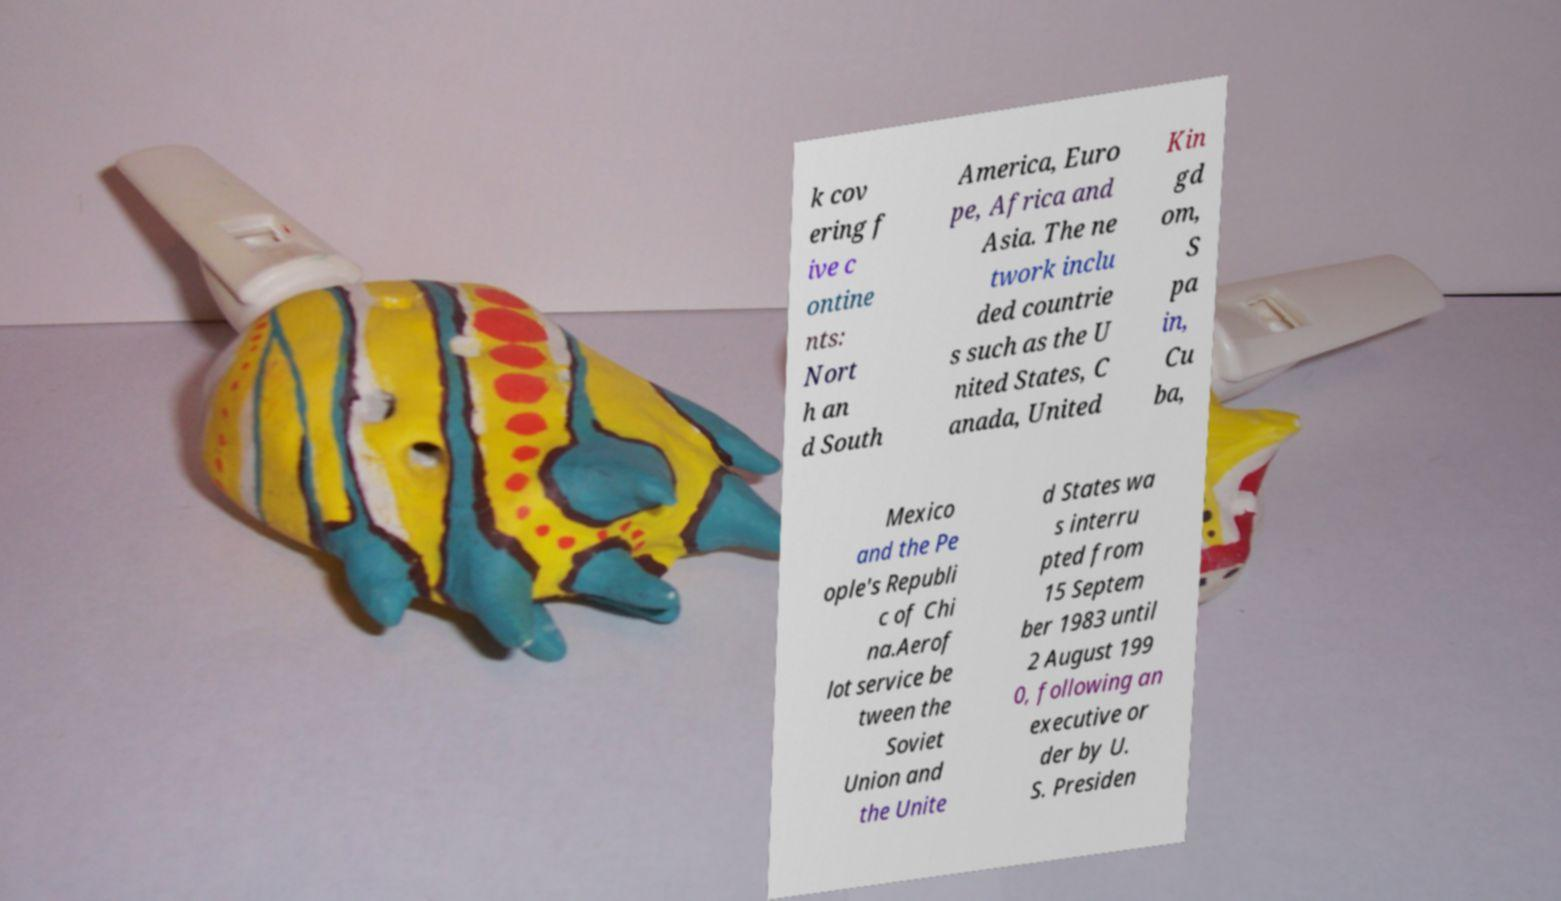Could you extract and type out the text from this image? k cov ering f ive c ontine nts: Nort h an d South America, Euro pe, Africa and Asia. The ne twork inclu ded countrie s such as the U nited States, C anada, United Kin gd om, S pa in, Cu ba, Mexico and the Pe ople's Republi c of Chi na.Aerof lot service be tween the Soviet Union and the Unite d States wa s interru pted from 15 Septem ber 1983 until 2 August 199 0, following an executive or der by U. S. Presiden 